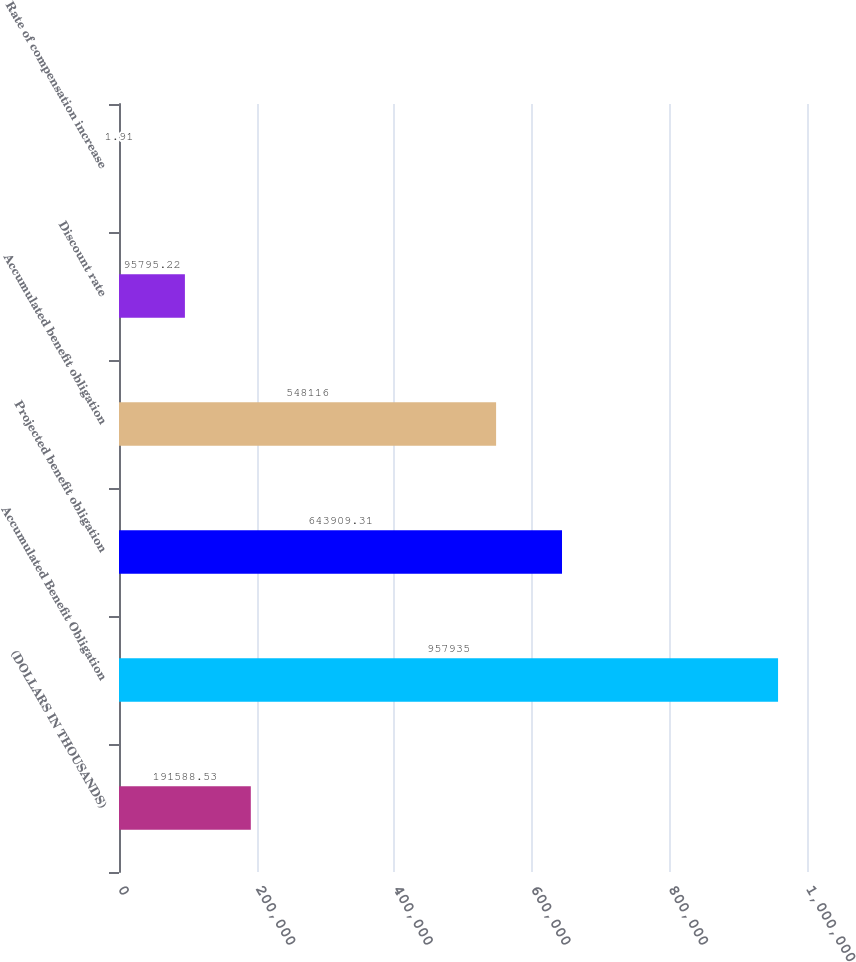Convert chart. <chart><loc_0><loc_0><loc_500><loc_500><bar_chart><fcel>(DOLLARS IN THOUSANDS)<fcel>Accumulated Benefit Obligation<fcel>Projected benefit obligation<fcel>Accumulated benefit obligation<fcel>Discount rate<fcel>Rate of compensation increase<nl><fcel>191589<fcel>957935<fcel>643909<fcel>548116<fcel>95795.2<fcel>1.91<nl></chart> 